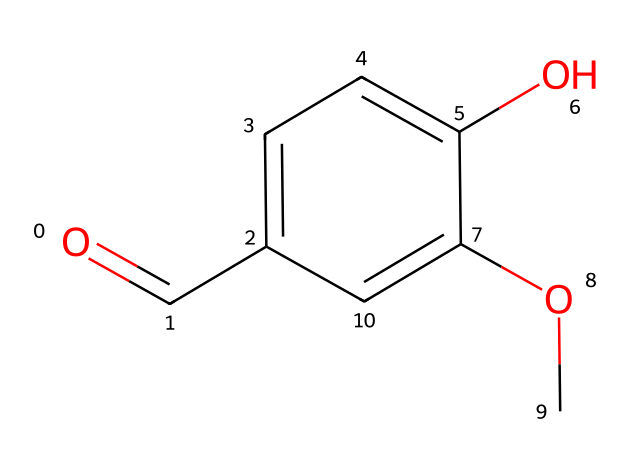What is the molecular formula of vanillin? To determine the molecular formula, we can look at each atom in the structure represented by the SMILES. Counting the carbon (C), hydrogen (H), and oxygen (O) atoms gives us 8 carbon atoms, 8 hydrogen atoms, and 3 oxygen atoms. Therefore, the molecular formula is C8H8O3.
Answer: C8H8O3 How many oxygen atoms are present in the structure? By visually inspecting the SMILES representation, we can see the presence of three 'O' characters, which indicates there are three oxygen atoms in the structure.
Answer: 3 What type of functional groups are present in vanillin? By analyzing the structure, we can identify that there is a carbonyl group (C=O) and a hydroxyl group (–OH) along with an ether group (R–O–R). This combination indicates that vanillin has aldehyde and alcohol functional groups.
Answer: aldehyde and alcohol What is the total number of rings in the structure? Upon examination of the structure represented by the SMILES, we can see that the chemical contains one benzene ring, indicating that there is only one ring present in the structure.
Answer: 1 What is the degree of substitution on the benzene ring? In the benzene part of the structure, we see two substituents: a hydroxyl group (–OH) and a methoxy group (–O–CH3), indicating that the benzene ring is substituted in two positions. Thus, the degree of substitution is 2.
Answer: 2 Does vanillin contain a chiral center? Looking at the structure, we assess the carbon atoms. None of them have four different substituents; therefore, there is no chiral center in the vanillin molecule.
Answer: no 